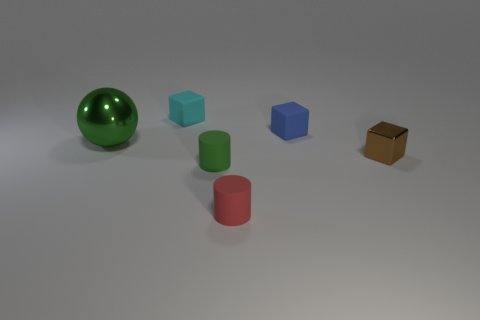Add 4 yellow matte cylinders. How many objects exist? 10 Subtract all cylinders. How many objects are left? 4 Subtract all large purple metal things. Subtract all green matte cylinders. How many objects are left? 5 Add 4 brown objects. How many brown objects are left? 5 Add 3 small gray cylinders. How many small gray cylinders exist? 3 Subtract 1 green spheres. How many objects are left? 5 